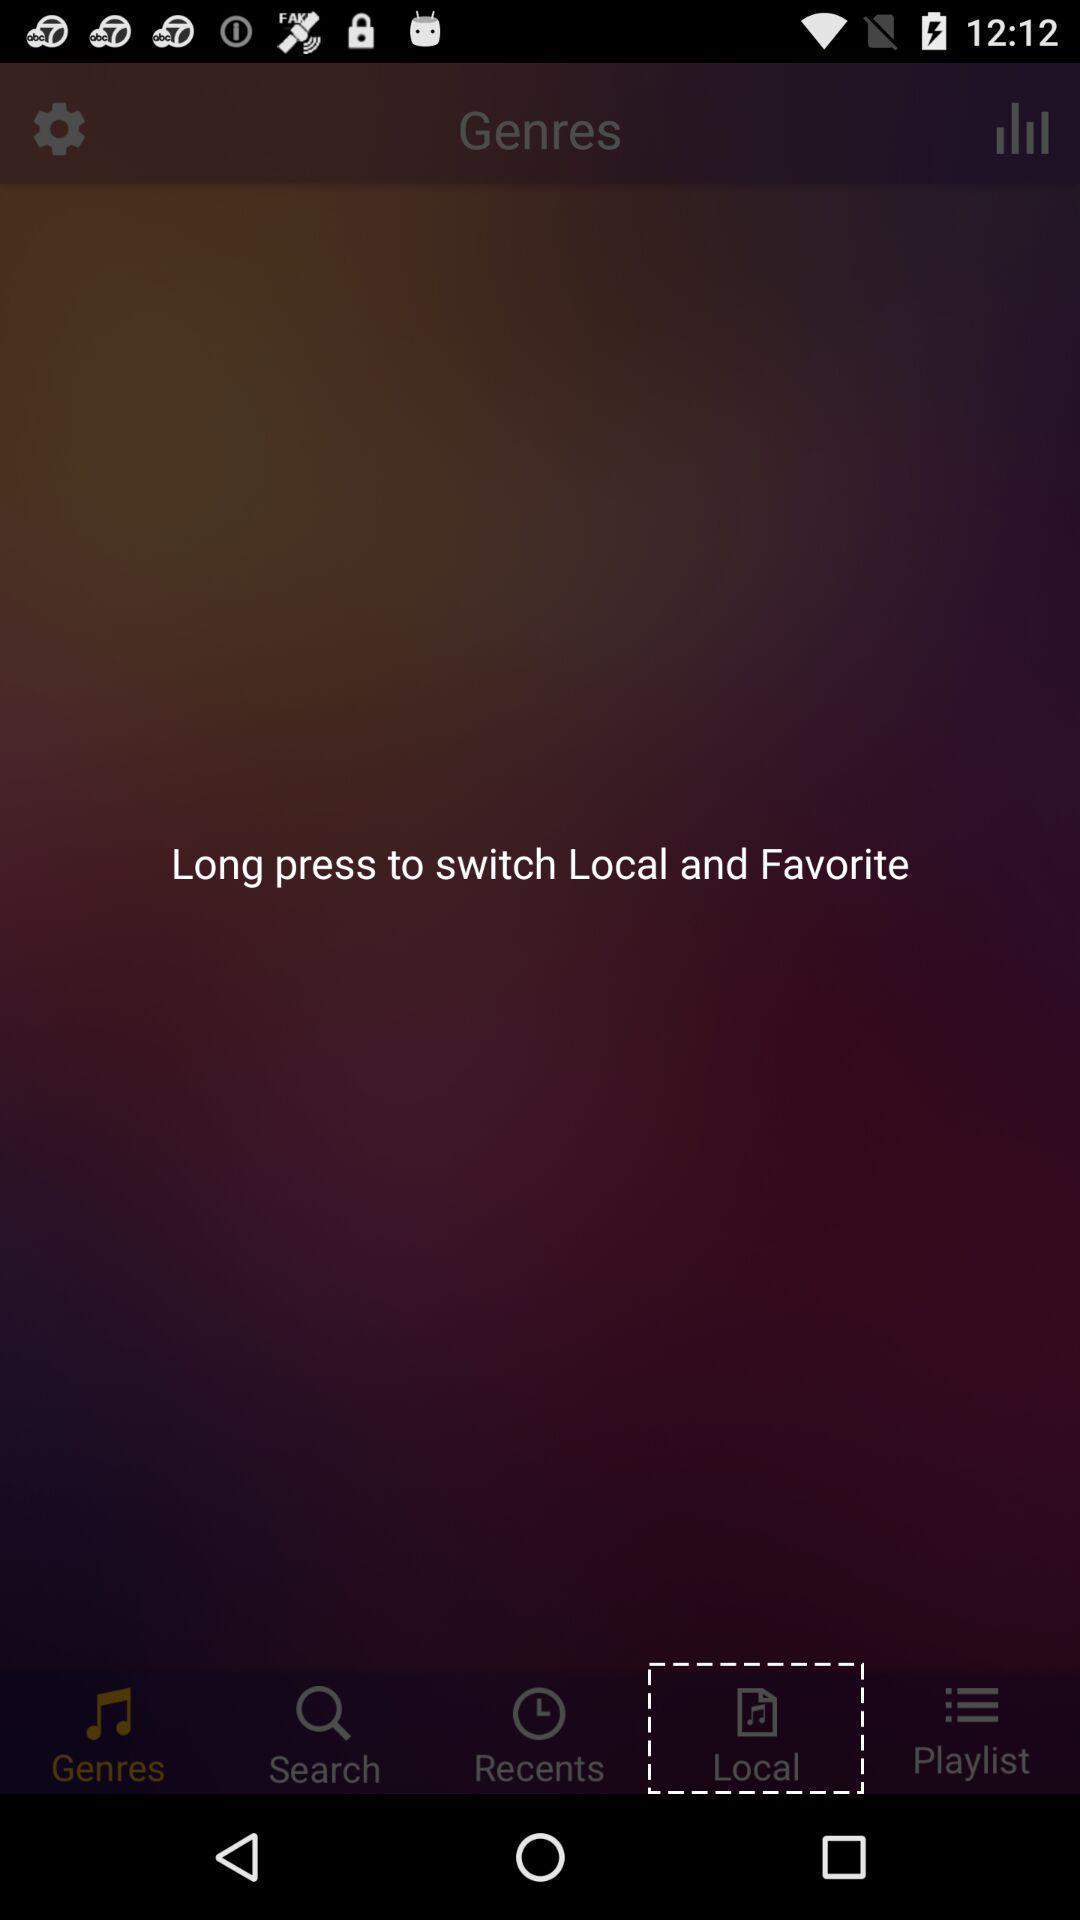Tell me what you see in this picture. Screen showing a local folder on a device. 